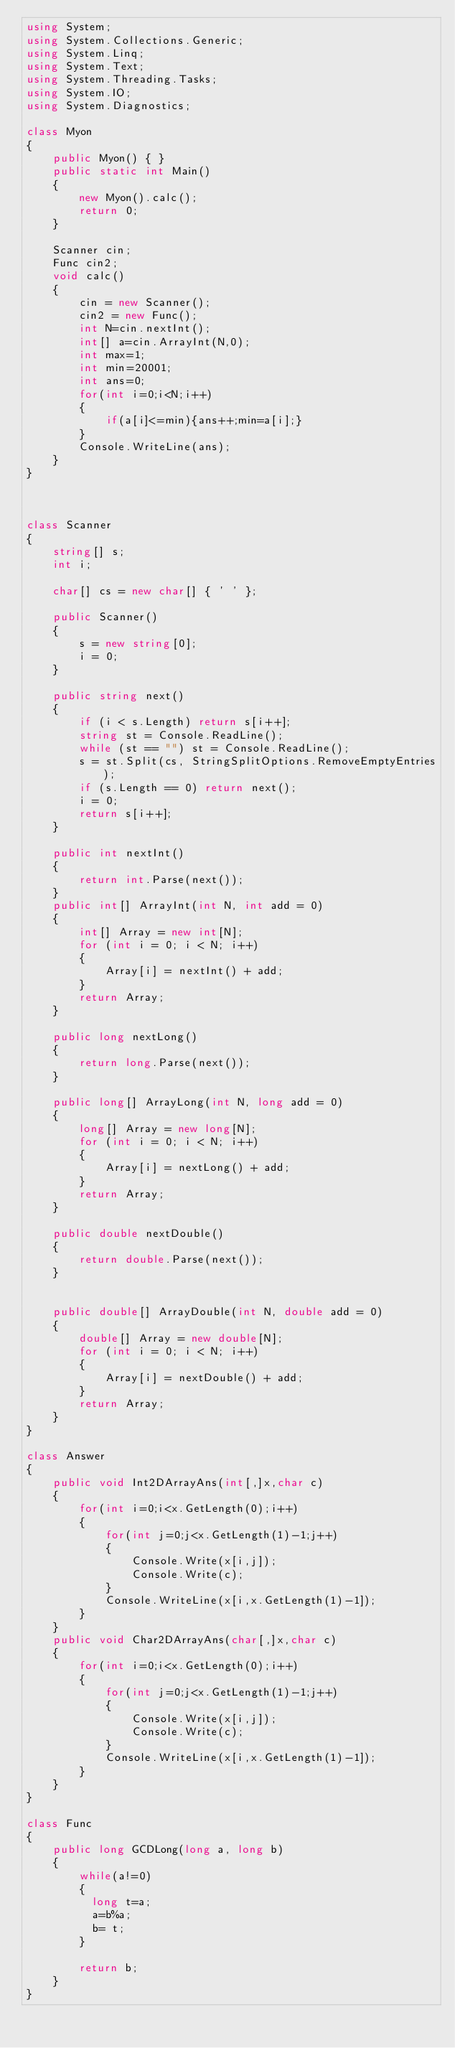Convert code to text. <code><loc_0><loc_0><loc_500><loc_500><_C#_>using System;
using System.Collections.Generic;
using System.Linq;
using System.Text;
using System.Threading.Tasks;
using System.IO;
using System.Diagnostics;

class Myon
{
    public Myon() { }
    public static int Main()
    {
        new Myon().calc();
        return 0;
    }

    Scanner cin;
    Func cin2;
    void calc()
    {
        cin = new Scanner();
        cin2 = new Func();
        int N=cin.nextInt();
        int[] a=cin.ArrayInt(N,0);
        int max=1;
        int min=20001;
        int ans=0;
        for(int i=0;i<N;i++)
        {
            if(a[i]<=min){ans++;min=a[i];}
        }
        Console.WriteLine(ans);
    }
}



class Scanner
{
    string[] s;
    int i;

    char[] cs = new char[] { ' ' };

    public Scanner()
    {
        s = new string[0];
        i = 0;
    }

    public string next()
    {
        if (i < s.Length) return s[i++];
        string st = Console.ReadLine();
        while (st == "") st = Console.ReadLine();
        s = st.Split(cs, StringSplitOptions.RemoveEmptyEntries);
        if (s.Length == 0) return next();
        i = 0;
        return s[i++];
    }

    public int nextInt()
    {
        return int.Parse(next());
    }
    public int[] ArrayInt(int N, int add = 0)
    {
        int[] Array = new int[N];
        for (int i = 0; i < N; i++)
        {
            Array[i] = nextInt() + add;
        }
        return Array;
    }

    public long nextLong()
    {
        return long.Parse(next());
    }

    public long[] ArrayLong(int N, long add = 0)
    {
        long[] Array = new long[N];
        for (int i = 0; i < N; i++)
        {
            Array[i] = nextLong() + add;
        }
        return Array;
    }

    public double nextDouble()
    {
        return double.Parse(next());
    }


    public double[] ArrayDouble(int N, double add = 0)
    {
        double[] Array = new double[N];
        for (int i = 0; i < N; i++)
        {
            Array[i] = nextDouble() + add;
        }
        return Array;
    }
}

class Answer
{
    public void Int2DArrayAns(int[,]x,char c)
    {
        for(int i=0;i<x.GetLength(0);i++)
        {
            for(int j=0;j<x.GetLength(1)-1;j++)
            {
                Console.Write(x[i,j]);
                Console.Write(c);
            }
            Console.WriteLine(x[i,x.GetLength(1)-1]);
        }
    }
    public void Char2DArrayAns(char[,]x,char c)
    {
        for(int i=0;i<x.GetLength(0);i++)
        {
            for(int j=0;j<x.GetLength(1)-1;j++)
            {
                Console.Write(x[i,j]);
                Console.Write(c);
            }
            Console.WriteLine(x[i,x.GetLength(1)-1]);
        }
    }
}

class Func
{
    public long GCDLong(long a, long b)
    {
        while(a!=0)
        {
          long t=a;
          a=b%a;
          b= t;
        }
      
        return b;        
    }
}</code> 